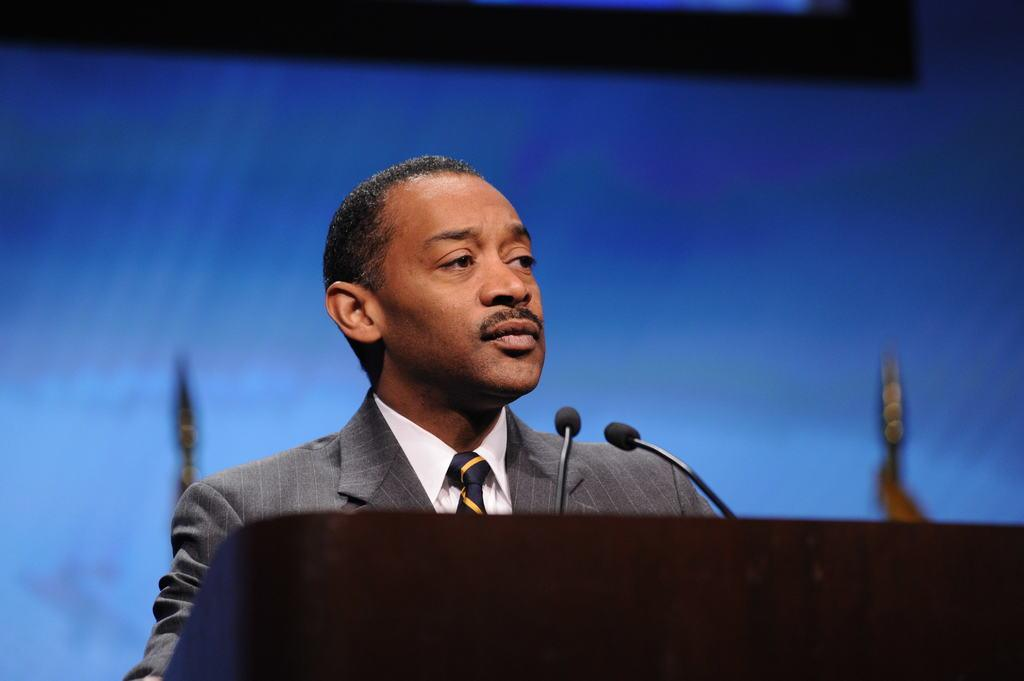Who is the main subject in the image? There is a man in the image. What is the man standing in front of? There are microphones on a podium in front of the man. Can you describe the background of the image? The background of the image is blurry. Where is the nest located in the image? There is no nest present in the image. What type of expansion is being discussed in the image? The image does not depict any discussion about expansion. 